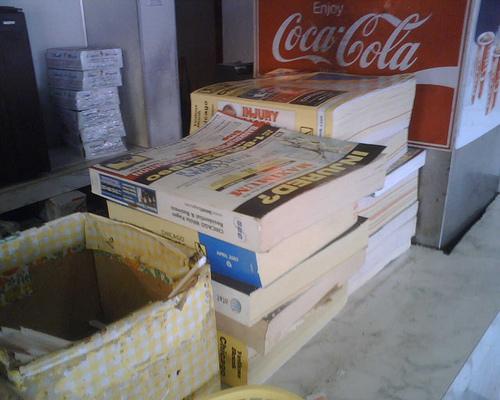Do you see a knife in the picture?
Quick response, please. No. What color is the tablecloth?
Keep it brief. White. What are in the little white squares behind the books?
Answer briefly. Cases of soda. How many stacks of phone books are visible?
Give a very brief answer. 2. What kind of books are these?
Short answer required. Phone. 